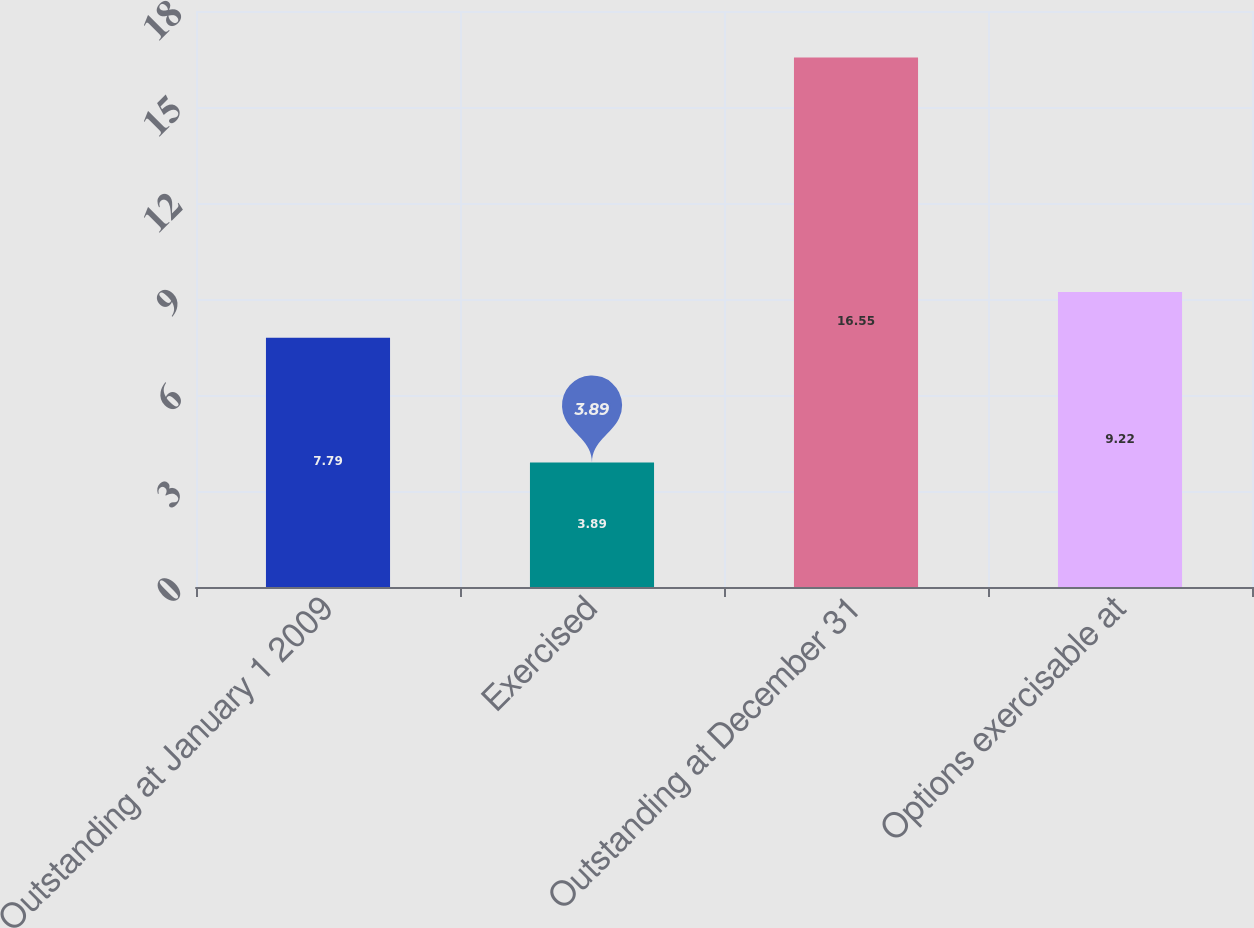<chart> <loc_0><loc_0><loc_500><loc_500><bar_chart><fcel>Outstanding at January 1 2009<fcel>Exercised<fcel>Outstanding at December 31<fcel>Options exercisable at<nl><fcel>7.79<fcel>3.89<fcel>16.55<fcel>9.22<nl></chart> 